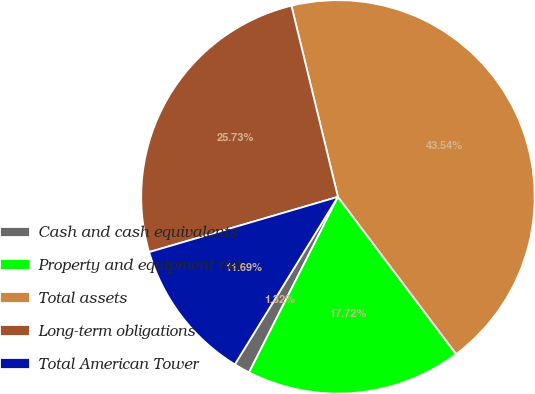<chart> <loc_0><loc_0><loc_500><loc_500><pie_chart><fcel>Cash and cash equivalents<fcel>Property and equipment net<fcel>Total assets<fcel>Long-term obligations<fcel>Total American Tower<nl><fcel>1.32%<fcel>17.72%<fcel>43.54%<fcel>25.73%<fcel>11.69%<nl></chart> 